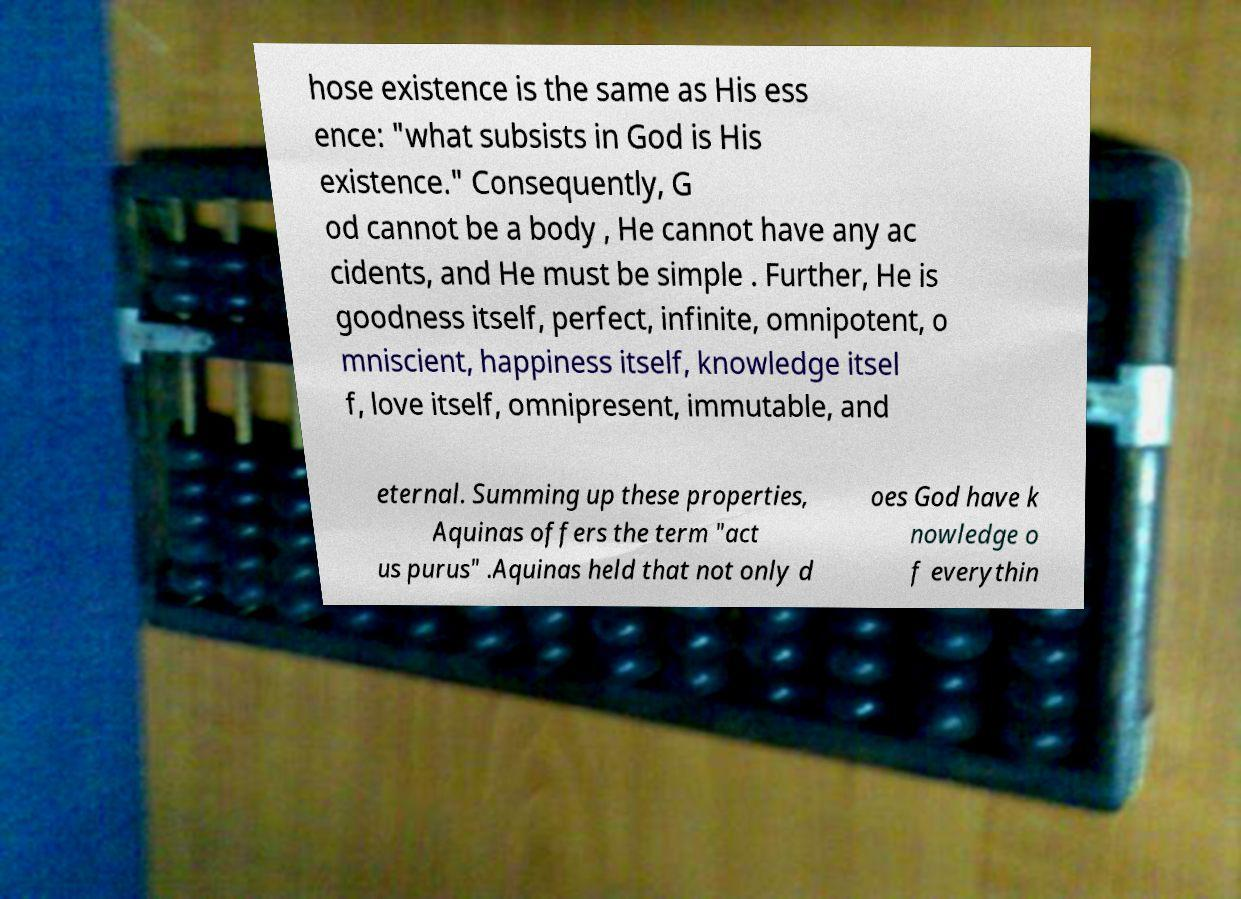I need the written content from this picture converted into text. Can you do that? hose existence is the same as His ess ence: "what subsists in God is His existence." Consequently, G od cannot be a body , He cannot have any ac cidents, and He must be simple . Further, He is goodness itself, perfect, infinite, omnipotent, o mniscient, happiness itself, knowledge itsel f, love itself, omnipresent, immutable, and eternal. Summing up these properties, Aquinas offers the term "act us purus" .Aquinas held that not only d oes God have k nowledge o f everythin 